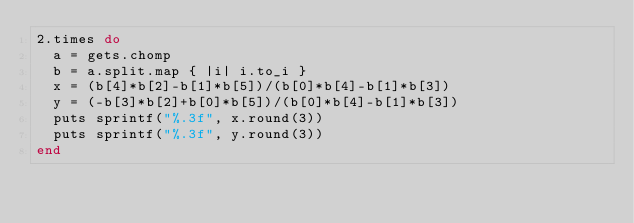Convert code to text. <code><loc_0><loc_0><loc_500><loc_500><_Ruby_>2.times do
	a = gets.chomp
	b = a.split.map { |i| i.to_i }
	x = (b[4]*b[2]-b[1]*b[5])/(b[0]*b[4]-b[1]*b[3])
	y = (-b[3]*b[2]+b[0]*b[5])/(b[0]*b[4]-b[1]*b[3])
	puts sprintf("%.3f", x.round(3))
	puts sprintf("%.3f", y.round(3))
end</code> 